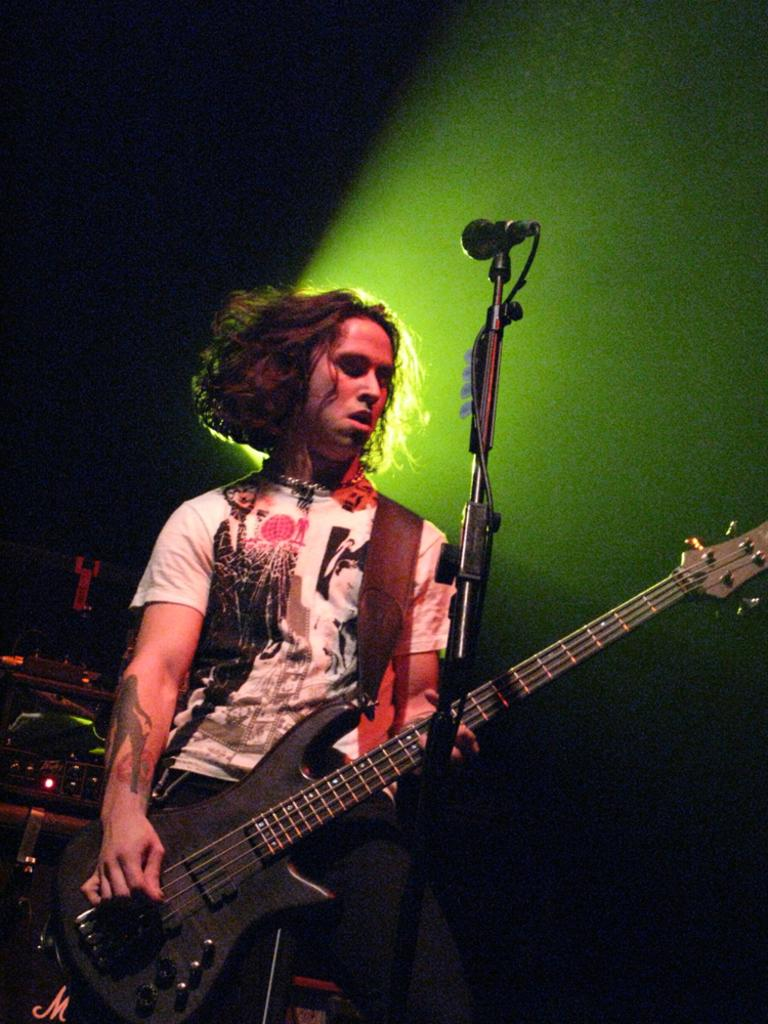What is the man in the image doing? The man is playing a guitar in the image. What object is in front of the man? There is a microphone in front of the man. What can be seen in the background of the image? There is a light in the background of the image. How would you describe the overall lighting in the image? The image appears to be dark. What type of engine can be seen in the image? There is no engine present in the image; it features a man playing a guitar with a microphone in front of him. How does the rake interact with the sand in the image? There is no rake or sand present in the image. 